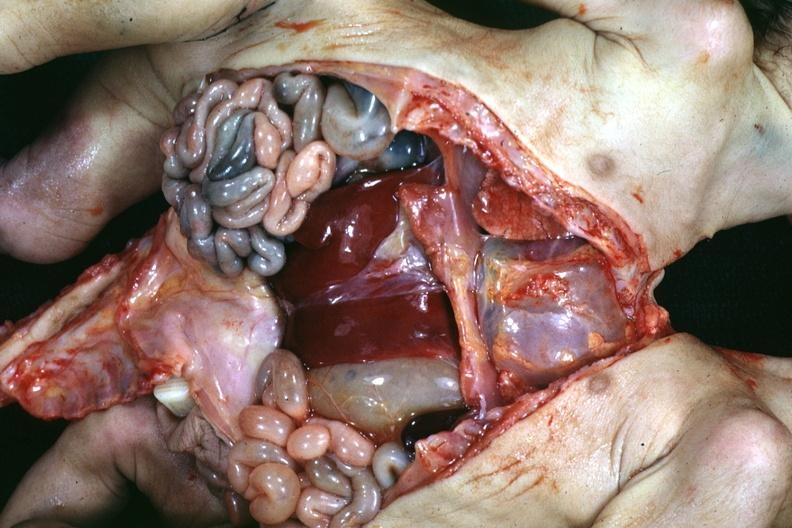what is lower chest and abdomen anterior opened?
Answer the question using a single word or phrase. Lower showing apparent two sets intestine with one liver 